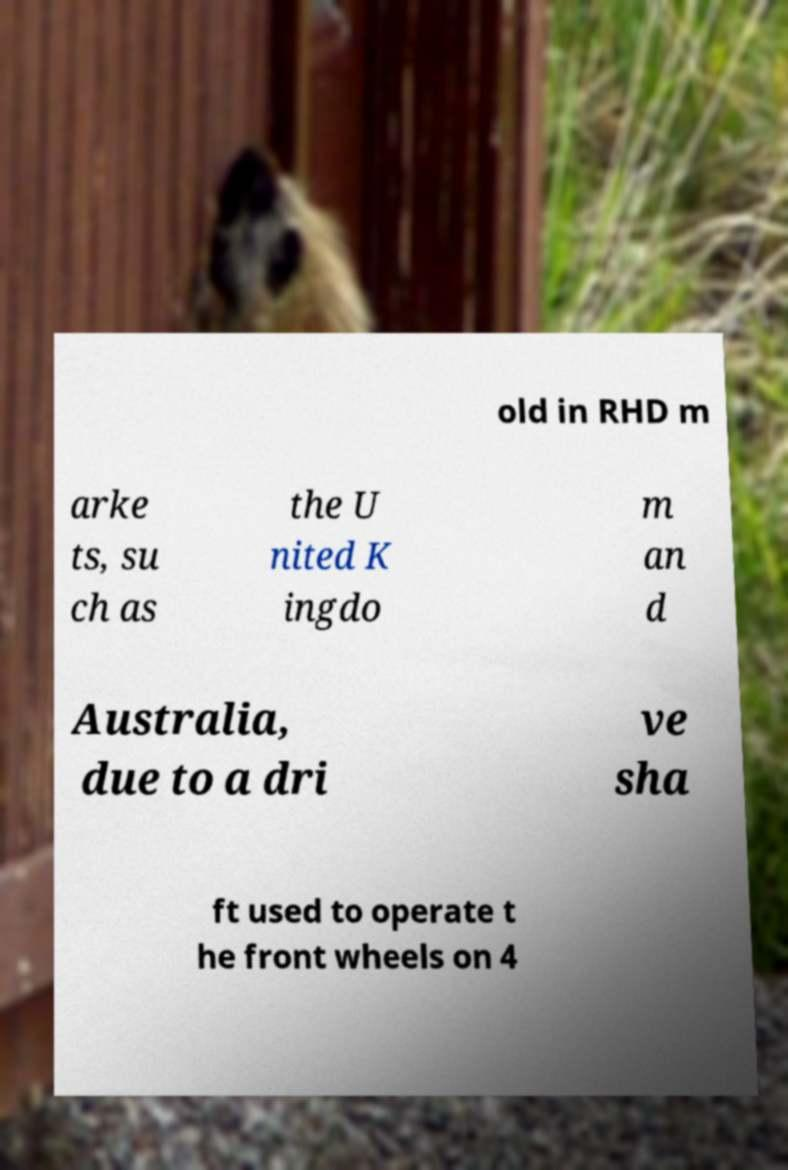There's text embedded in this image that I need extracted. Can you transcribe it verbatim? old in RHD m arke ts, su ch as the U nited K ingdo m an d Australia, due to a dri ve sha ft used to operate t he front wheels on 4 